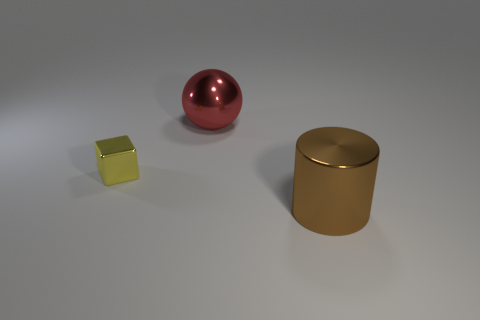There is a metal thing that is left of the large metallic object that is behind the yellow metal object; is there a brown cylinder to the left of it?
Ensure brevity in your answer.  No. What shape is the other thing that is the same size as the red metallic thing?
Provide a short and direct response. Cylinder. What number of small objects are red metal balls or blue metallic cylinders?
Your answer should be compact. 0. The small object that is the same material as the large sphere is what color?
Ensure brevity in your answer.  Yellow. There is a object that is behind the small yellow block; is its shape the same as the thing in front of the tiny yellow shiny cube?
Provide a succinct answer. No. What number of rubber things are green spheres or big balls?
Keep it short and to the point. 0. Are there any other things that have the same shape as the yellow metallic thing?
Offer a terse response. No. What is the material of the large object in front of the block?
Offer a terse response. Metal. Does the big object in front of the yellow object have the same material as the small yellow object?
Your answer should be compact. Yes. How many things are either metallic blocks or large metallic objects that are left of the cylinder?
Offer a very short reply. 2. 